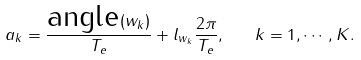<formula> <loc_0><loc_0><loc_500><loc_500>a _ { k } = \frac { \text {angle} ( w _ { k } ) } { T _ { e } } + l _ { w _ { k } } \frac { 2 \pi } { T _ { e } } , \quad k = 1 , \cdots , K .</formula> 